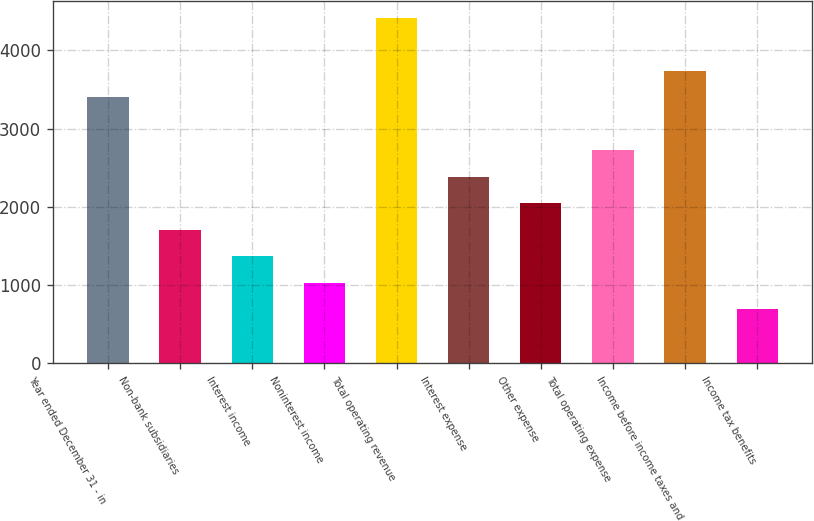Convert chart to OTSL. <chart><loc_0><loc_0><loc_500><loc_500><bar_chart><fcel>Year ended December 31 - in<fcel>Non-bank subsidiaries<fcel>Interest income<fcel>Noninterest income<fcel>Total operating revenue<fcel>Interest expense<fcel>Other expense<fcel>Total operating expense<fcel>Income before income taxes and<fcel>Income tax benefits<nl><fcel>3398<fcel>1707.5<fcel>1369.4<fcel>1031.3<fcel>4412.3<fcel>2383.7<fcel>2045.6<fcel>2721.8<fcel>3736.1<fcel>693.2<nl></chart> 